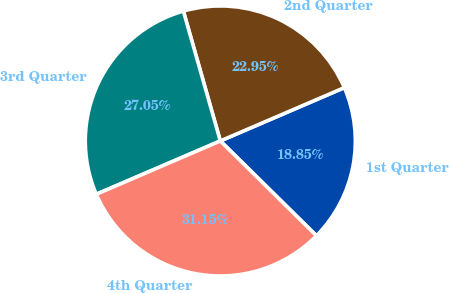<chart> <loc_0><loc_0><loc_500><loc_500><pie_chart><fcel>1st Quarter<fcel>2nd Quarter<fcel>3rd Quarter<fcel>4th Quarter<nl><fcel>18.85%<fcel>22.95%<fcel>27.05%<fcel>31.15%<nl></chart> 